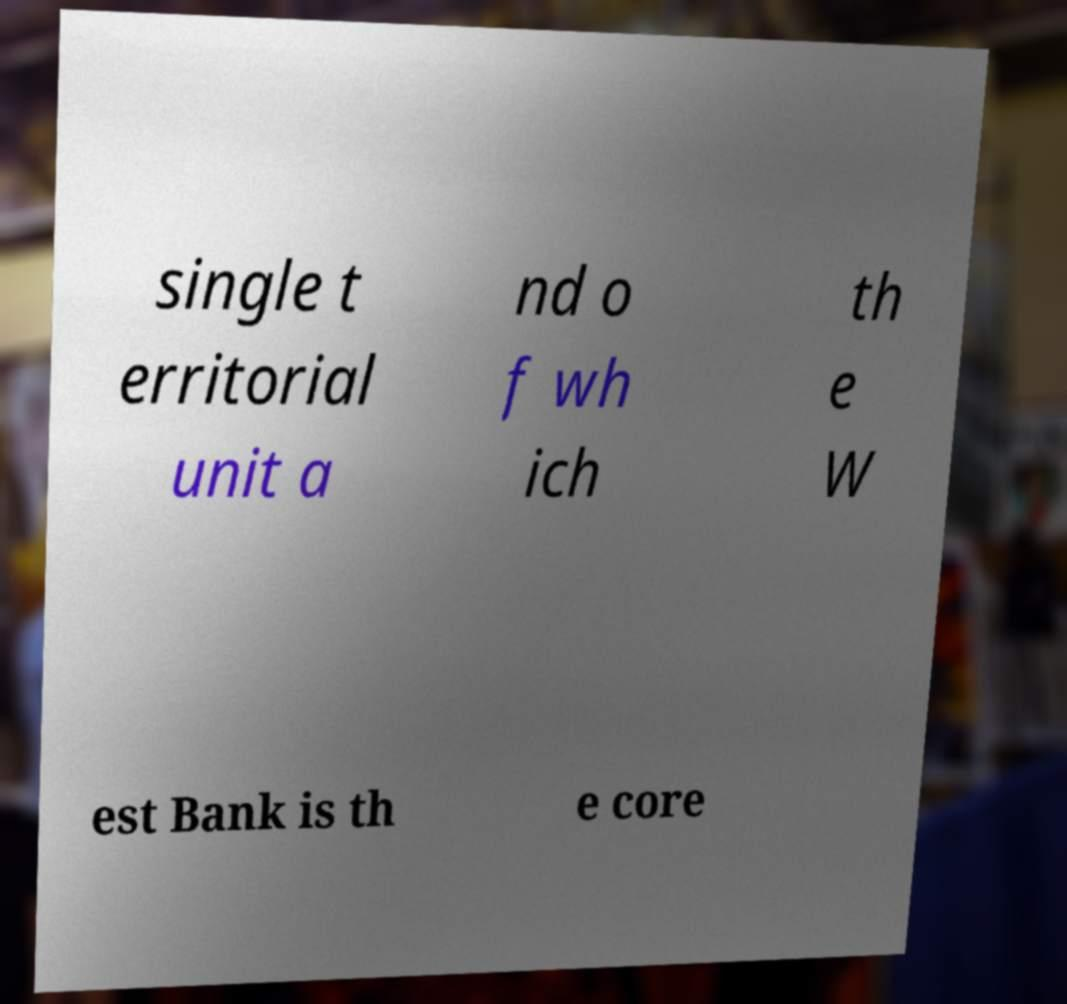Can you read and provide the text displayed in the image?This photo seems to have some interesting text. Can you extract and type it out for me? single t erritorial unit a nd o f wh ich th e W est Bank is th e core 